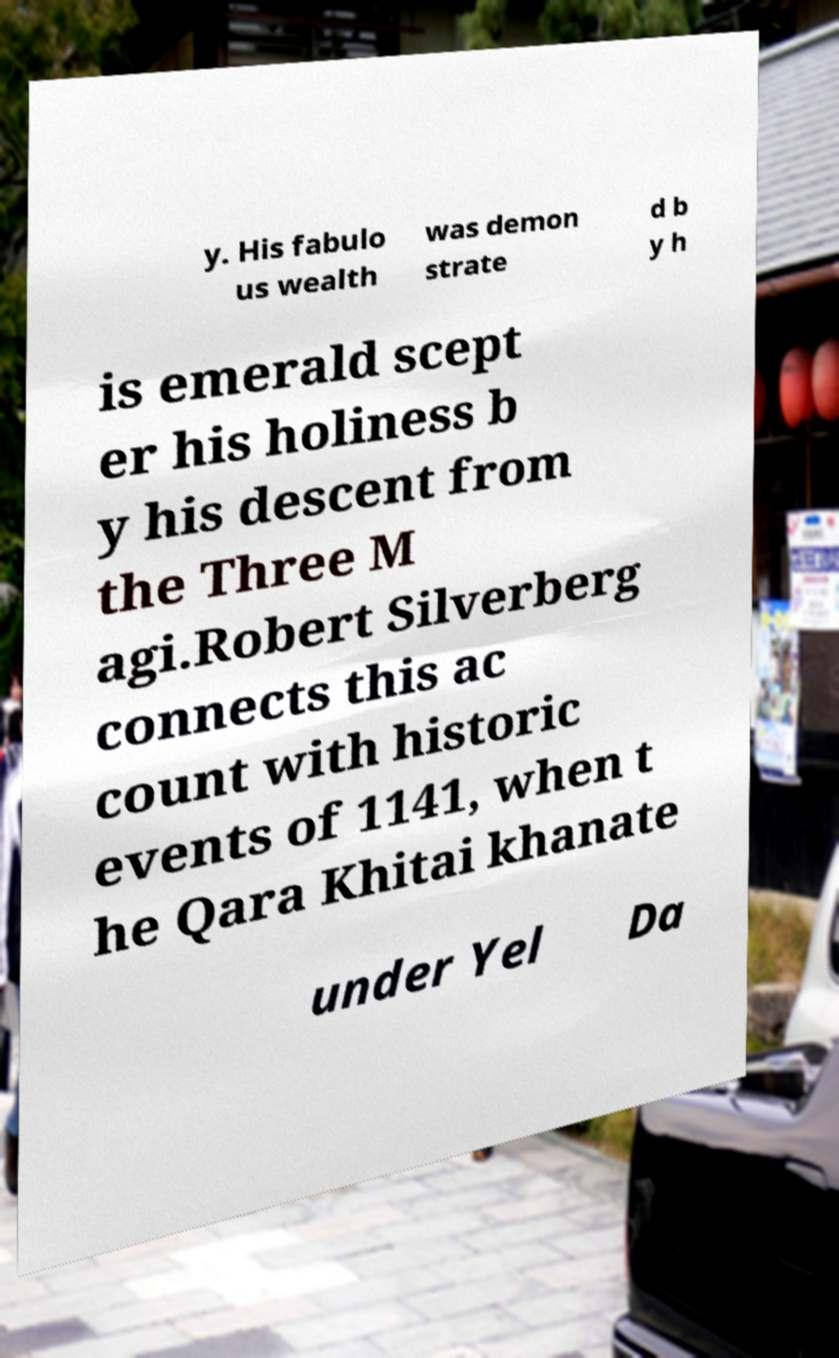Please read and relay the text visible in this image. What does it say? y. His fabulo us wealth was demon strate d b y h is emerald scept er his holiness b y his descent from the Three M agi.Robert Silverberg connects this ac count with historic events of 1141, when t he Qara Khitai khanate under Yel Da 